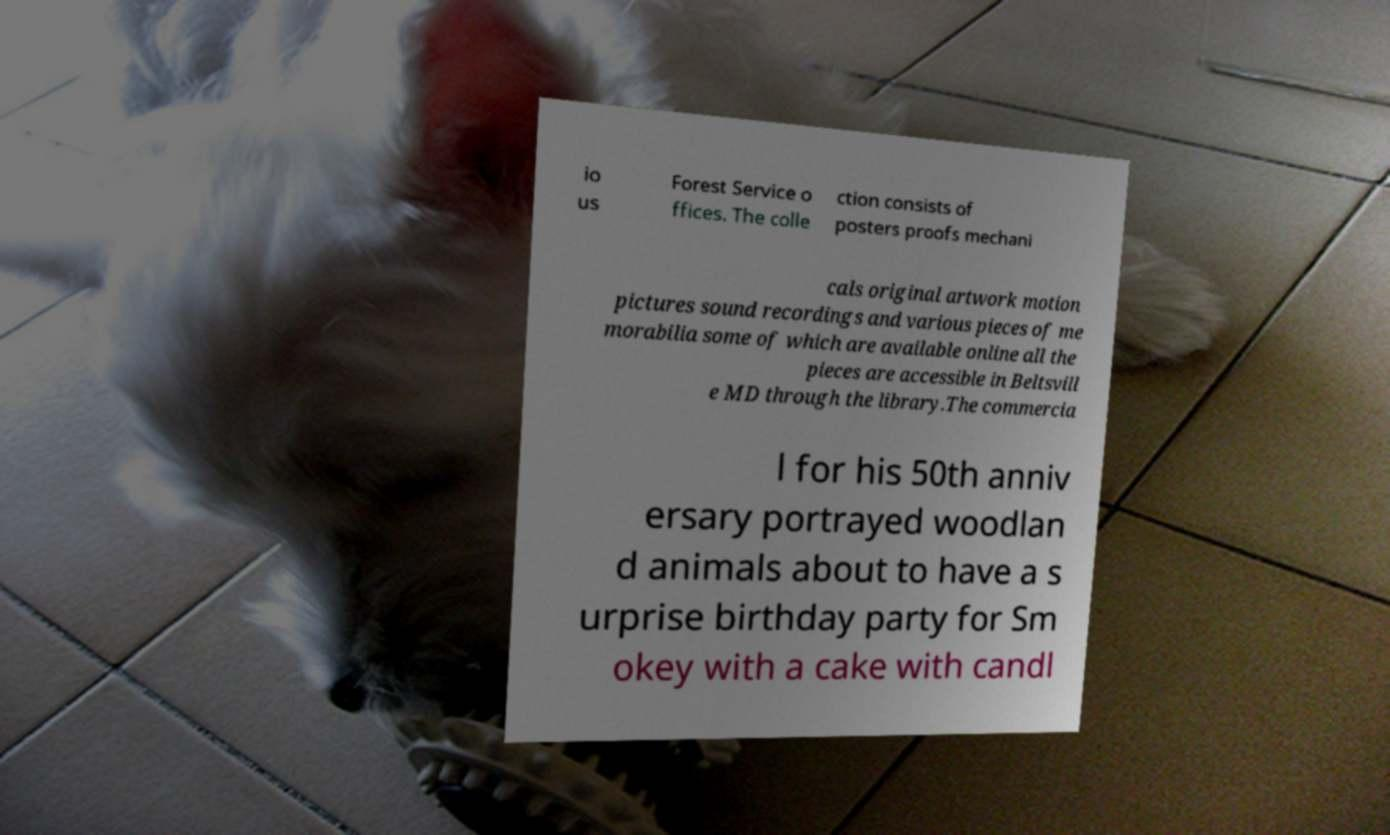Could you assist in decoding the text presented in this image and type it out clearly? io us Forest Service o ffices. The colle ction consists of posters proofs mechani cals original artwork motion pictures sound recordings and various pieces of me morabilia some of which are available online all the pieces are accessible in Beltsvill e MD through the library.The commercia l for his 50th anniv ersary portrayed woodlan d animals about to have a s urprise birthday party for Sm okey with a cake with candl 